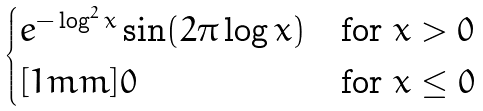Convert formula to latex. <formula><loc_0><loc_0><loc_500><loc_500>\begin{cases} e ^ { - \log ^ { 2 } x } \sin ( 2 \pi \log x ) & \text {for } x > 0 \\ [ 1 m m ] 0 & \text {for } x \leq 0 \end{cases}</formula> 